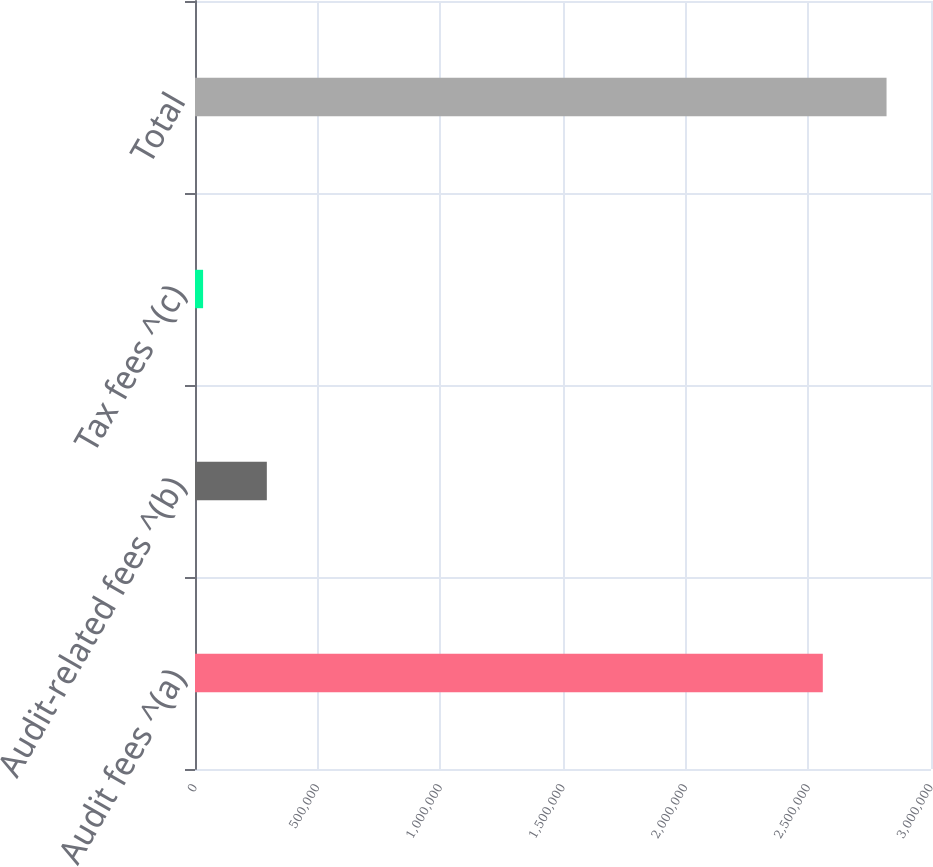Convert chart. <chart><loc_0><loc_0><loc_500><loc_500><bar_chart><fcel>Audit fees ^(a)<fcel>Audit-related fees ^(b)<fcel>Tax fees ^(c)<fcel>Total<nl><fcel>2.559e+06<fcel>292800<fcel>33000<fcel>2.8188e+06<nl></chart> 